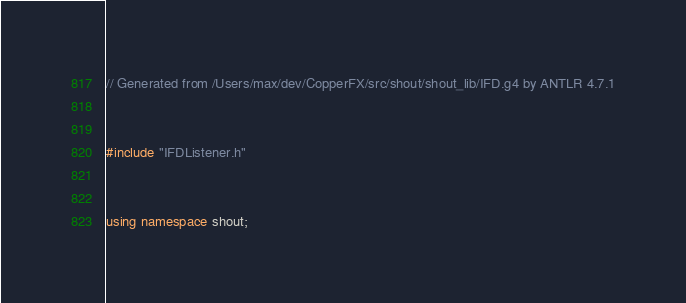Convert code to text. <code><loc_0><loc_0><loc_500><loc_500><_C++_>
// Generated from /Users/max/dev/CopperFX/src/shout/shout_lib/IFD.g4 by ANTLR 4.7.1


#include "IFDListener.h"


using namespace shout;

</code> 